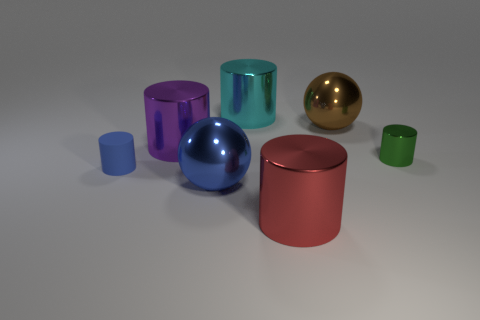Subtract all small green cylinders. How many cylinders are left? 4 Add 2 big brown metallic balls. How many objects exist? 9 Subtract 2 cylinders. How many cylinders are left? 3 Subtract all green cylinders. How many cylinders are left? 4 Subtract all red cylinders. Subtract all gray balls. How many cylinders are left? 4 Add 2 small cylinders. How many small cylinders are left? 4 Add 3 big cylinders. How many big cylinders exist? 6 Subtract 1 blue spheres. How many objects are left? 6 Subtract all balls. How many objects are left? 5 Subtract all green objects. Subtract all small green shiny things. How many objects are left? 5 